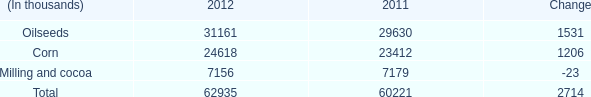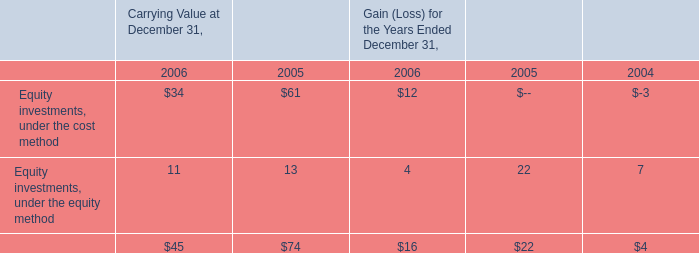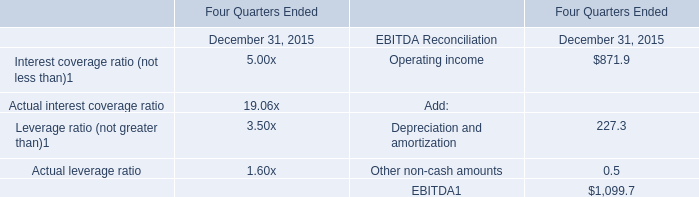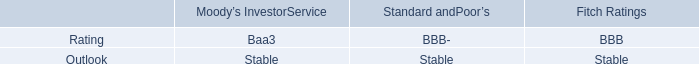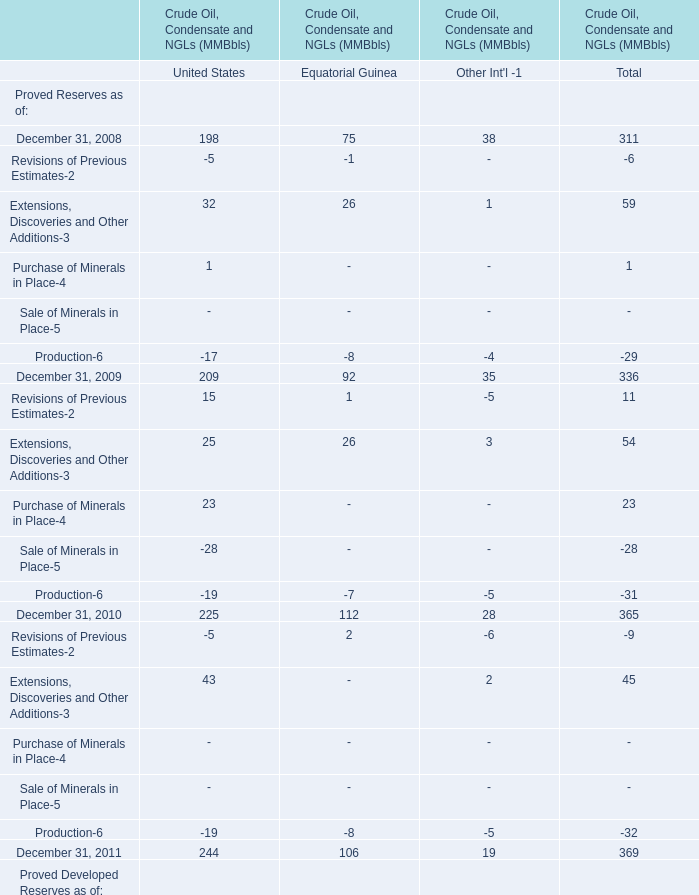What is the growing rate of Proved Undeveloped Reserves as of Equatorial Guinea in the years with the least Proved Developed Reserves as of United State? (in %) 
Computations: ((43 - 49) / 49)
Answer: -0.12245. 